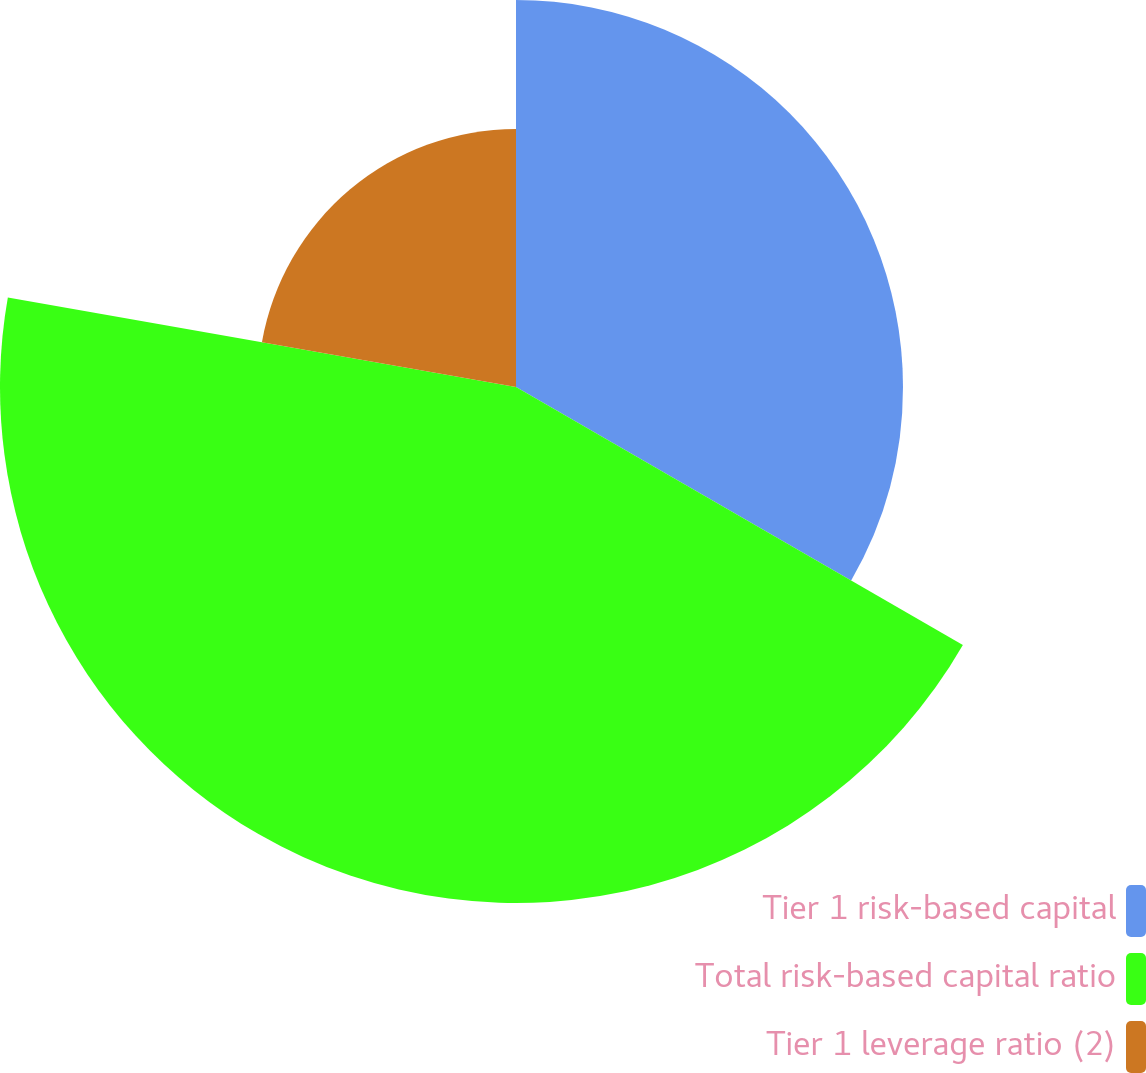<chart> <loc_0><loc_0><loc_500><loc_500><pie_chart><fcel>Tier 1 risk-based capital<fcel>Total risk-based capital ratio<fcel>Tier 1 leverage ratio (2)<nl><fcel>33.33%<fcel>44.44%<fcel>22.22%<nl></chart> 